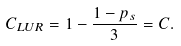Convert formula to latex. <formula><loc_0><loc_0><loc_500><loc_500>C _ { L U R } = 1 - \frac { 1 - p _ { s } } { 3 } = C .</formula> 